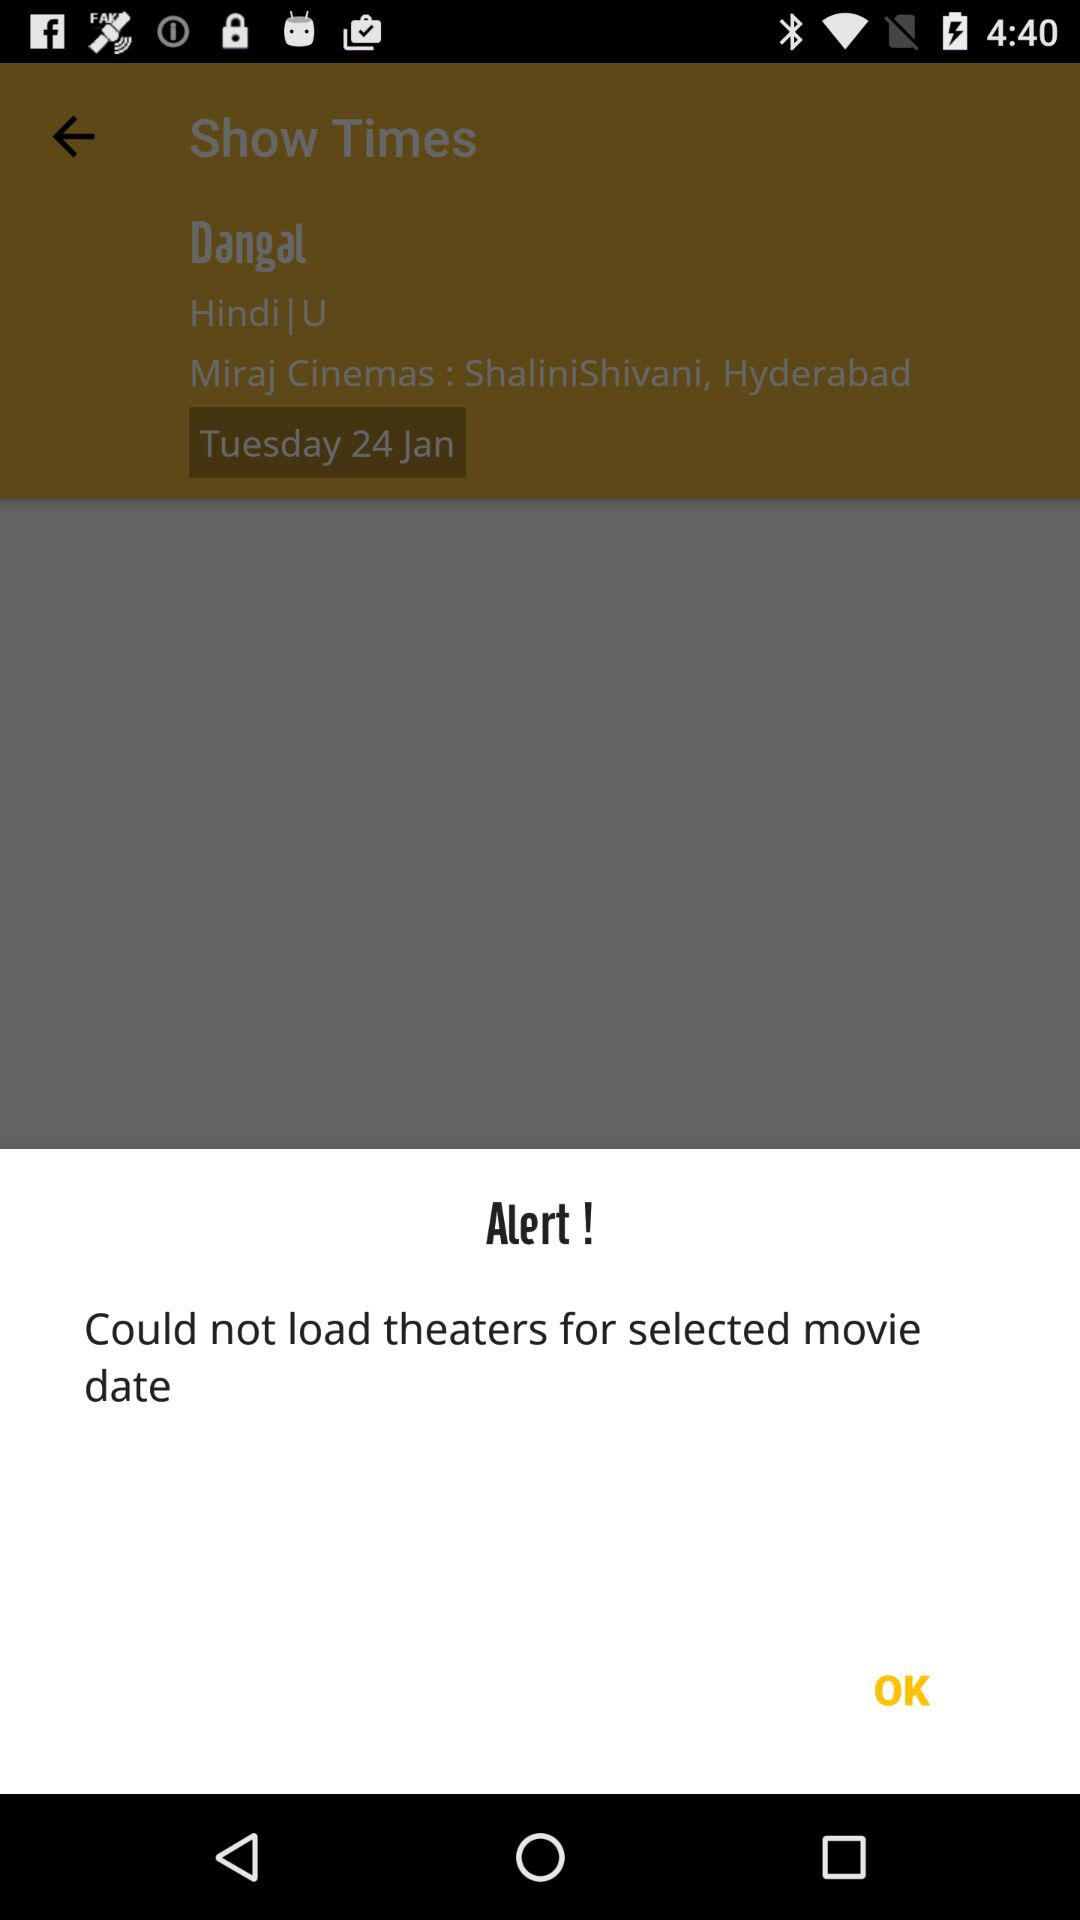On which date will the show be booked? The show will be booked on January 24. 